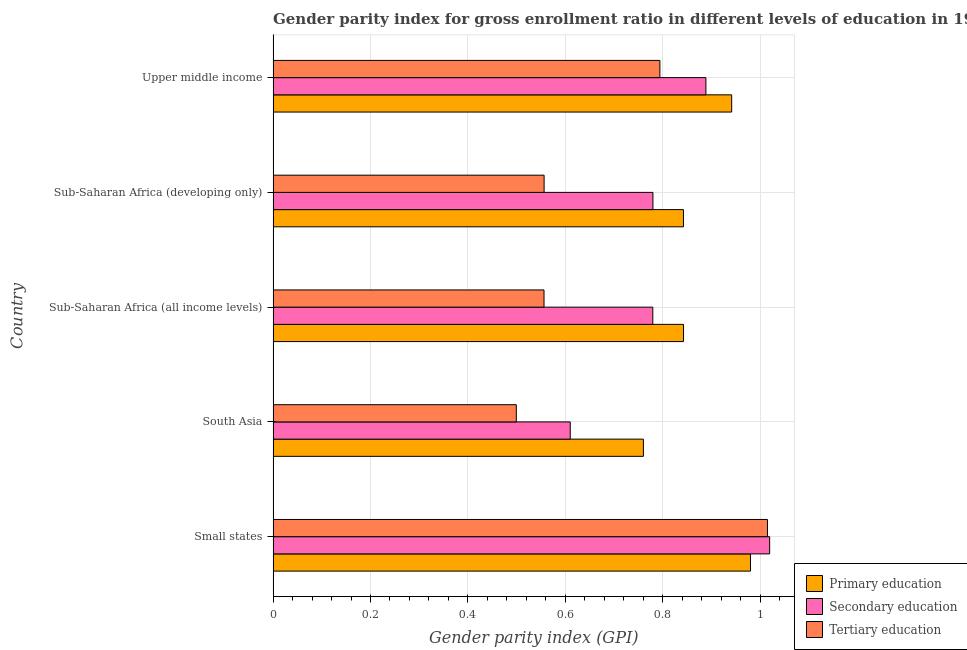How many groups of bars are there?
Provide a short and direct response. 5. Are the number of bars on each tick of the Y-axis equal?
Your answer should be compact. Yes. How many bars are there on the 4th tick from the top?
Provide a short and direct response. 3. How many bars are there on the 4th tick from the bottom?
Ensure brevity in your answer.  3. What is the label of the 4th group of bars from the top?
Provide a short and direct response. South Asia. In how many cases, is the number of bars for a given country not equal to the number of legend labels?
Offer a terse response. 0. What is the gender parity index in tertiary education in South Asia?
Provide a succinct answer. 0.5. Across all countries, what is the maximum gender parity index in tertiary education?
Ensure brevity in your answer.  1.02. Across all countries, what is the minimum gender parity index in primary education?
Your answer should be compact. 0.76. In which country was the gender parity index in secondary education maximum?
Provide a short and direct response. Small states. In which country was the gender parity index in tertiary education minimum?
Keep it short and to the point. South Asia. What is the total gender parity index in tertiary education in the graph?
Keep it short and to the point. 3.42. What is the difference between the gender parity index in tertiary education in Small states and that in Sub-Saharan Africa (developing only)?
Your response must be concise. 0.46. What is the difference between the gender parity index in secondary education in South Asia and the gender parity index in primary education in Sub-Saharan Africa (all income levels)?
Ensure brevity in your answer.  -0.23. What is the average gender parity index in primary education per country?
Provide a succinct answer. 0.87. What is the difference between the gender parity index in tertiary education and gender parity index in secondary education in South Asia?
Keep it short and to the point. -0.11. What is the ratio of the gender parity index in secondary education in Small states to that in Sub-Saharan Africa (all income levels)?
Your response must be concise. 1.31. What is the difference between the highest and the second highest gender parity index in primary education?
Your response must be concise. 0.04. What is the difference between the highest and the lowest gender parity index in primary education?
Give a very brief answer. 0.22. In how many countries, is the gender parity index in tertiary education greater than the average gender parity index in tertiary education taken over all countries?
Provide a succinct answer. 2. Is the sum of the gender parity index in primary education in Small states and Sub-Saharan Africa (all income levels) greater than the maximum gender parity index in tertiary education across all countries?
Your answer should be compact. Yes. What does the 3rd bar from the top in South Asia represents?
Provide a short and direct response. Primary education. What does the 2nd bar from the bottom in Sub-Saharan Africa (all income levels) represents?
Offer a terse response. Secondary education. Are all the bars in the graph horizontal?
Offer a very short reply. Yes. How many countries are there in the graph?
Offer a terse response. 5. Are the values on the major ticks of X-axis written in scientific E-notation?
Give a very brief answer. No. Does the graph contain any zero values?
Give a very brief answer. No. Does the graph contain grids?
Your answer should be compact. Yes. Where does the legend appear in the graph?
Provide a short and direct response. Bottom right. How are the legend labels stacked?
Your response must be concise. Vertical. What is the title of the graph?
Keep it short and to the point. Gender parity index for gross enrollment ratio in different levels of education in 1992. What is the label or title of the X-axis?
Make the answer very short. Gender parity index (GPI). What is the label or title of the Y-axis?
Provide a short and direct response. Country. What is the Gender parity index (GPI) in Primary education in Small states?
Your answer should be very brief. 0.98. What is the Gender parity index (GPI) of Secondary education in Small states?
Your answer should be compact. 1.02. What is the Gender parity index (GPI) in Tertiary education in Small states?
Offer a very short reply. 1.02. What is the Gender parity index (GPI) in Primary education in South Asia?
Offer a very short reply. 0.76. What is the Gender parity index (GPI) in Secondary education in South Asia?
Provide a short and direct response. 0.61. What is the Gender parity index (GPI) in Tertiary education in South Asia?
Provide a short and direct response. 0.5. What is the Gender parity index (GPI) in Primary education in Sub-Saharan Africa (all income levels)?
Your answer should be very brief. 0.84. What is the Gender parity index (GPI) in Secondary education in Sub-Saharan Africa (all income levels)?
Provide a succinct answer. 0.78. What is the Gender parity index (GPI) of Tertiary education in Sub-Saharan Africa (all income levels)?
Provide a short and direct response. 0.56. What is the Gender parity index (GPI) in Primary education in Sub-Saharan Africa (developing only)?
Your answer should be very brief. 0.84. What is the Gender parity index (GPI) of Secondary education in Sub-Saharan Africa (developing only)?
Your answer should be compact. 0.78. What is the Gender parity index (GPI) of Tertiary education in Sub-Saharan Africa (developing only)?
Offer a terse response. 0.56. What is the Gender parity index (GPI) of Primary education in Upper middle income?
Your response must be concise. 0.94. What is the Gender parity index (GPI) in Secondary education in Upper middle income?
Offer a terse response. 0.89. What is the Gender parity index (GPI) in Tertiary education in Upper middle income?
Your response must be concise. 0.79. Across all countries, what is the maximum Gender parity index (GPI) of Primary education?
Your answer should be compact. 0.98. Across all countries, what is the maximum Gender parity index (GPI) in Secondary education?
Your response must be concise. 1.02. Across all countries, what is the maximum Gender parity index (GPI) in Tertiary education?
Provide a short and direct response. 1.02. Across all countries, what is the minimum Gender parity index (GPI) in Primary education?
Offer a terse response. 0.76. Across all countries, what is the minimum Gender parity index (GPI) of Secondary education?
Give a very brief answer. 0.61. Across all countries, what is the minimum Gender parity index (GPI) in Tertiary education?
Offer a terse response. 0.5. What is the total Gender parity index (GPI) of Primary education in the graph?
Your response must be concise. 4.37. What is the total Gender parity index (GPI) of Secondary education in the graph?
Give a very brief answer. 4.08. What is the total Gender parity index (GPI) in Tertiary education in the graph?
Ensure brevity in your answer.  3.42. What is the difference between the Gender parity index (GPI) in Primary education in Small states and that in South Asia?
Your answer should be very brief. 0.22. What is the difference between the Gender parity index (GPI) of Secondary education in Small states and that in South Asia?
Keep it short and to the point. 0.41. What is the difference between the Gender parity index (GPI) of Tertiary education in Small states and that in South Asia?
Your response must be concise. 0.52. What is the difference between the Gender parity index (GPI) of Primary education in Small states and that in Sub-Saharan Africa (all income levels)?
Offer a very short reply. 0.14. What is the difference between the Gender parity index (GPI) in Secondary education in Small states and that in Sub-Saharan Africa (all income levels)?
Your answer should be compact. 0.24. What is the difference between the Gender parity index (GPI) of Tertiary education in Small states and that in Sub-Saharan Africa (all income levels)?
Give a very brief answer. 0.46. What is the difference between the Gender parity index (GPI) in Primary education in Small states and that in Sub-Saharan Africa (developing only)?
Offer a terse response. 0.14. What is the difference between the Gender parity index (GPI) of Secondary education in Small states and that in Sub-Saharan Africa (developing only)?
Your answer should be compact. 0.24. What is the difference between the Gender parity index (GPI) in Tertiary education in Small states and that in Sub-Saharan Africa (developing only)?
Offer a very short reply. 0.46. What is the difference between the Gender parity index (GPI) of Primary education in Small states and that in Upper middle income?
Ensure brevity in your answer.  0.04. What is the difference between the Gender parity index (GPI) in Secondary education in Small states and that in Upper middle income?
Keep it short and to the point. 0.13. What is the difference between the Gender parity index (GPI) of Tertiary education in Small states and that in Upper middle income?
Your answer should be compact. 0.22. What is the difference between the Gender parity index (GPI) of Primary education in South Asia and that in Sub-Saharan Africa (all income levels)?
Ensure brevity in your answer.  -0.08. What is the difference between the Gender parity index (GPI) of Secondary education in South Asia and that in Sub-Saharan Africa (all income levels)?
Offer a terse response. -0.17. What is the difference between the Gender parity index (GPI) in Tertiary education in South Asia and that in Sub-Saharan Africa (all income levels)?
Ensure brevity in your answer.  -0.06. What is the difference between the Gender parity index (GPI) of Primary education in South Asia and that in Sub-Saharan Africa (developing only)?
Offer a very short reply. -0.08. What is the difference between the Gender parity index (GPI) in Secondary education in South Asia and that in Sub-Saharan Africa (developing only)?
Keep it short and to the point. -0.17. What is the difference between the Gender parity index (GPI) of Tertiary education in South Asia and that in Sub-Saharan Africa (developing only)?
Make the answer very short. -0.06. What is the difference between the Gender parity index (GPI) in Primary education in South Asia and that in Upper middle income?
Offer a very short reply. -0.18. What is the difference between the Gender parity index (GPI) of Secondary education in South Asia and that in Upper middle income?
Your answer should be compact. -0.28. What is the difference between the Gender parity index (GPI) in Tertiary education in South Asia and that in Upper middle income?
Your response must be concise. -0.29. What is the difference between the Gender parity index (GPI) in Primary education in Sub-Saharan Africa (all income levels) and that in Sub-Saharan Africa (developing only)?
Your response must be concise. 0. What is the difference between the Gender parity index (GPI) of Secondary education in Sub-Saharan Africa (all income levels) and that in Sub-Saharan Africa (developing only)?
Your answer should be compact. -0. What is the difference between the Gender parity index (GPI) in Tertiary education in Sub-Saharan Africa (all income levels) and that in Sub-Saharan Africa (developing only)?
Ensure brevity in your answer.  -0. What is the difference between the Gender parity index (GPI) of Primary education in Sub-Saharan Africa (all income levels) and that in Upper middle income?
Provide a short and direct response. -0.1. What is the difference between the Gender parity index (GPI) of Secondary education in Sub-Saharan Africa (all income levels) and that in Upper middle income?
Make the answer very short. -0.11. What is the difference between the Gender parity index (GPI) of Tertiary education in Sub-Saharan Africa (all income levels) and that in Upper middle income?
Offer a terse response. -0.24. What is the difference between the Gender parity index (GPI) of Primary education in Sub-Saharan Africa (developing only) and that in Upper middle income?
Provide a succinct answer. -0.1. What is the difference between the Gender parity index (GPI) in Secondary education in Sub-Saharan Africa (developing only) and that in Upper middle income?
Offer a terse response. -0.11. What is the difference between the Gender parity index (GPI) of Tertiary education in Sub-Saharan Africa (developing only) and that in Upper middle income?
Provide a short and direct response. -0.24. What is the difference between the Gender parity index (GPI) of Primary education in Small states and the Gender parity index (GPI) of Secondary education in South Asia?
Your response must be concise. 0.37. What is the difference between the Gender parity index (GPI) of Primary education in Small states and the Gender parity index (GPI) of Tertiary education in South Asia?
Give a very brief answer. 0.48. What is the difference between the Gender parity index (GPI) of Secondary education in Small states and the Gender parity index (GPI) of Tertiary education in South Asia?
Give a very brief answer. 0.52. What is the difference between the Gender parity index (GPI) of Primary education in Small states and the Gender parity index (GPI) of Secondary education in Sub-Saharan Africa (all income levels)?
Keep it short and to the point. 0.2. What is the difference between the Gender parity index (GPI) in Primary education in Small states and the Gender parity index (GPI) in Tertiary education in Sub-Saharan Africa (all income levels)?
Ensure brevity in your answer.  0.42. What is the difference between the Gender parity index (GPI) of Secondary education in Small states and the Gender parity index (GPI) of Tertiary education in Sub-Saharan Africa (all income levels)?
Ensure brevity in your answer.  0.46. What is the difference between the Gender parity index (GPI) of Primary education in Small states and the Gender parity index (GPI) of Secondary education in Sub-Saharan Africa (developing only)?
Offer a terse response. 0.2. What is the difference between the Gender parity index (GPI) in Primary education in Small states and the Gender parity index (GPI) in Tertiary education in Sub-Saharan Africa (developing only)?
Your response must be concise. 0.42. What is the difference between the Gender parity index (GPI) of Secondary education in Small states and the Gender parity index (GPI) of Tertiary education in Sub-Saharan Africa (developing only)?
Offer a terse response. 0.46. What is the difference between the Gender parity index (GPI) in Primary education in Small states and the Gender parity index (GPI) in Secondary education in Upper middle income?
Offer a terse response. 0.09. What is the difference between the Gender parity index (GPI) of Primary education in Small states and the Gender parity index (GPI) of Tertiary education in Upper middle income?
Provide a succinct answer. 0.19. What is the difference between the Gender parity index (GPI) of Secondary education in Small states and the Gender parity index (GPI) of Tertiary education in Upper middle income?
Your answer should be compact. 0.23. What is the difference between the Gender parity index (GPI) of Primary education in South Asia and the Gender parity index (GPI) of Secondary education in Sub-Saharan Africa (all income levels)?
Provide a succinct answer. -0.02. What is the difference between the Gender parity index (GPI) in Primary education in South Asia and the Gender parity index (GPI) in Tertiary education in Sub-Saharan Africa (all income levels)?
Offer a terse response. 0.2. What is the difference between the Gender parity index (GPI) in Secondary education in South Asia and the Gender parity index (GPI) in Tertiary education in Sub-Saharan Africa (all income levels)?
Make the answer very short. 0.05. What is the difference between the Gender parity index (GPI) in Primary education in South Asia and the Gender parity index (GPI) in Secondary education in Sub-Saharan Africa (developing only)?
Give a very brief answer. -0.02. What is the difference between the Gender parity index (GPI) in Primary education in South Asia and the Gender parity index (GPI) in Tertiary education in Sub-Saharan Africa (developing only)?
Keep it short and to the point. 0.2. What is the difference between the Gender parity index (GPI) in Secondary education in South Asia and the Gender parity index (GPI) in Tertiary education in Sub-Saharan Africa (developing only)?
Offer a very short reply. 0.05. What is the difference between the Gender parity index (GPI) in Primary education in South Asia and the Gender parity index (GPI) in Secondary education in Upper middle income?
Provide a short and direct response. -0.13. What is the difference between the Gender parity index (GPI) in Primary education in South Asia and the Gender parity index (GPI) in Tertiary education in Upper middle income?
Your answer should be compact. -0.03. What is the difference between the Gender parity index (GPI) of Secondary education in South Asia and the Gender parity index (GPI) of Tertiary education in Upper middle income?
Offer a very short reply. -0.18. What is the difference between the Gender parity index (GPI) in Primary education in Sub-Saharan Africa (all income levels) and the Gender parity index (GPI) in Secondary education in Sub-Saharan Africa (developing only)?
Provide a succinct answer. 0.06. What is the difference between the Gender parity index (GPI) of Primary education in Sub-Saharan Africa (all income levels) and the Gender parity index (GPI) of Tertiary education in Sub-Saharan Africa (developing only)?
Ensure brevity in your answer.  0.29. What is the difference between the Gender parity index (GPI) in Secondary education in Sub-Saharan Africa (all income levels) and the Gender parity index (GPI) in Tertiary education in Sub-Saharan Africa (developing only)?
Offer a very short reply. 0.22. What is the difference between the Gender parity index (GPI) of Primary education in Sub-Saharan Africa (all income levels) and the Gender parity index (GPI) of Secondary education in Upper middle income?
Give a very brief answer. -0.05. What is the difference between the Gender parity index (GPI) in Primary education in Sub-Saharan Africa (all income levels) and the Gender parity index (GPI) in Tertiary education in Upper middle income?
Provide a short and direct response. 0.05. What is the difference between the Gender parity index (GPI) of Secondary education in Sub-Saharan Africa (all income levels) and the Gender parity index (GPI) of Tertiary education in Upper middle income?
Provide a succinct answer. -0.01. What is the difference between the Gender parity index (GPI) of Primary education in Sub-Saharan Africa (developing only) and the Gender parity index (GPI) of Secondary education in Upper middle income?
Keep it short and to the point. -0.05. What is the difference between the Gender parity index (GPI) of Primary education in Sub-Saharan Africa (developing only) and the Gender parity index (GPI) of Tertiary education in Upper middle income?
Your answer should be very brief. 0.05. What is the difference between the Gender parity index (GPI) in Secondary education in Sub-Saharan Africa (developing only) and the Gender parity index (GPI) in Tertiary education in Upper middle income?
Your answer should be compact. -0.01. What is the average Gender parity index (GPI) in Primary education per country?
Ensure brevity in your answer.  0.87. What is the average Gender parity index (GPI) of Secondary education per country?
Offer a terse response. 0.82. What is the average Gender parity index (GPI) in Tertiary education per country?
Provide a short and direct response. 0.68. What is the difference between the Gender parity index (GPI) in Primary education and Gender parity index (GPI) in Secondary education in Small states?
Give a very brief answer. -0.04. What is the difference between the Gender parity index (GPI) of Primary education and Gender parity index (GPI) of Tertiary education in Small states?
Your answer should be compact. -0.03. What is the difference between the Gender parity index (GPI) in Secondary education and Gender parity index (GPI) in Tertiary education in Small states?
Ensure brevity in your answer.  0. What is the difference between the Gender parity index (GPI) in Primary education and Gender parity index (GPI) in Secondary education in South Asia?
Your answer should be compact. 0.15. What is the difference between the Gender parity index (GPI) of Primary education and Gender parity index (GPI) of Tertiary education in South Asia?
Give a very brief answer. 0.26. What is the difference between the Gender parity index (GPI) of Secondary education and Gender parity index (GPI) of Tertiary education in South Asia?
Your answer should be very brief. 0.11. What is the difference between the Gender parity index (GPI) in Primary education and Gender parity index (GPI) in Secondary education in Sub-Saharan Africa (all income levels)?
Your answer should be very brief. 0.06. What is the difference between the Gender parity index (GPI) in Primary education and Gender parity index (GPI) in Tertiary education in Sub-Saharan Africa (all income levels)?
Make the answer very short. 0.29. What is the difference between the Gender parity index (GPI) in Secondary education and Gender parity index (GPI) in Tertiary education in Sub-Saharan Africa (all income levels)?
Provide a succinct answer. 0.22. What is the difference between the Gender parity index (GPI) in Primary education and Gender parity index (GPI) in Secondary education in Sub-Saharan Africa (developing only)?
Make the answer very short. 0.06. What is the difference between the Gender parity index (GPI) in Primary education and Gender parity index (GPI) in Tertiary education in Sub-Saharan Africa (developing only)?
Make the answer very short. 0.29. What is the difference between the Gender parity index (GPI) in Secondary education and Gender parity index (GPI) in Tertiary education in Sub-Saharan Africa (developing only)?
Provide a succinct answer. 0.22. What is the difference between the Gender parity index (GPI) in Primary education and Gender parity index (GPI) in Secondary education in Upper middle income?
Offer a very short reply. 0.05. What is the difference between the Gender parity index (GPI) of Primary education and Gender parity index (GPI) of Tertiary education in Upper middle income?
Ensure brevity in your answer.  0.15. What is the difference between the Gender parity index (GPI) of Secondary education and Gender parity index (GPI) of Tertiary education in Upper middle income?
Provide a short and direct response. 0.09. What is the ratio of the Gender parity index (GPI) in Primary education in Small states to that in South Asia?
Provide a short and direct response. 1.29. What is the ratio of the Gender parity index (GPI) in Secondary education in Small states to that in South Asia?
Provide a short and direct response. 1.67. What is the ratio of the Gender parity index (GPI) of Tertiary education in Small states to that in South Asia?
Provide a short and direct response. 2.03. What is the ratio of the Gender parity index (GPI) of Primary education in Small states to that in Sub-Saharan Africa (all income levels)?
Offer a very short reply. 1.16. What is the ratio of the Gender parity index (GPI) in Secondary education in Small states to that in Sub-Saharan Africa (all income levels)?
Your answer should be very brief. 1.31. What is the ratio of the Gender parity index (GPI) in Tertiary education in Small states to that in Sub-Saharan Africa (all income levels)?
Offer a very short reply. 1.82. What is the ratio of the Gender parity index (GPI) of Primary education in Small states to that in Sub-Saharan Africa (developing only)?
Your answer should be compact. 1.16. What is the ratio of the Gender parity index (GPI) of Secondary education in Small states to that in Sub-Saharan Africa (developing only)?
Your answer should be very brief. 1.31. What is the ratio of the Gender parity index (GPI) of Tertiary education in Small states to that in Sub-Saharan Africa (developing only)?
Offer a very short reply. 1.82. What is the ratio of the Gender parity index (GPI) in Primary education in Small states to that in Upper middle income?
Ensure brevity in your answer.  1.04. What is the ratio of the Gender parity index (GPI) of Secondary education in Small states to that in Upper middle income?
Keep it short and to the point. 1.15. What is the ratio of the Gender parity index (GPI) of Tertiary education in Small states to that in Upper middle income?
Your response must be concise. 1.28. What is the ratio of the Gender parity index (GPI) in Primary education in South Asia to that in Sub-Saharan Africa (all income levels)?
Provide a short and direct response. 0.9. What is the ratio of the Gender parity index (GPI) of Secondary education in South Asia to that in Sub-Saharan Africa (all income levels)?
Make the answer very short. 0.78. What is the ratio of the Gender parity index (GPI) in Tertiary education in South Asia to that in Sub-Saharan Africa (all income levels)?
Your answer should be very brief. 0.9. What is the ratio of the Gender parity index (GPI) of Primary education in South Asia to that in Sub-Saharan Africa (developing only)?
Provide a succinct answer. 0.9. What is the ratio of the Gender parity index (GPI) in Secondary education in South Asia to that in Sub-Saharan Africa (developing only)?
Your answer should be very brief. 0.78. What is the ratio of the Gender parity index (GPI) of Tertiary education in South Asia to that in Sub-Saharan Africa (developing only)?
Provide a short and direct response. 0.9. What is the ratio of the Gender parity index (GPI) in Primary education in South Asia to that in Upper middle income?
Provide a succinct answer. 0.81. What is the ratio of the Gender parity index (GPI) of Secondary education in South Asia to that in Upper middle income?
Your answer should be very brief. 0.69. What is the ratio of the Gender parity index (GPI) of Tertiary education in South Asia to that in Upper middle income?
Offer a very short reply. 0.63. What is the ratio of the Gender parity index (GPI) in Tertiary education in Sub-Saharan Africa (all income levels) to that in Sub-Saharan Africa (developing only)?
Your answer should be very brief. 1. What is the ratio of the Gender parity index (GPI) in Primary education in Sub-Saharan Africa (all income levels) to that in Upper middle income?
Your answer should be very brief. 0.9. What is the ratio of the Gender parity index (GPI) in Secondary education in Sub-Saharan Africa (all income levels) to that in Upper middle income?
Keep it short and to the point. 0.88. What is the ratio of the Gender parity index (GPI) of Tertiary education in Sub-Saharan Africa (all income levels) to that in Upper middle income?
Your answer should be compact. 0.7. What is the ratio of the Gender parity index (GPI) in Primary education in Sub-Saharan Africa (developing only) to that in Upper middle income?
Offer a very short reply. 0.89. What is the ratio of the Gender parity index (GPI) of Secondary education in Sub-Saharan Africa (developing only) to that in Upper middle income?
Provide a succinct answer. 0.88. What is the ratio of the Gender parity index (GPI) in Tertiary education in Sub-Saharan Africa (developing only) to that in Upper middle income?
Ensure brevity in your answer.  0.7. What is the difference between the highest and the second highest Gender parity index (GPI) of Primary education?
Your answer should be very brief. 0.04. What is the difference between the highest and the second highest Gender parity index (GPI) in Secondary education?
Your answer should be compact. 0.13. What is the difference between the highest and the second highest Gender parity index (GPI) of Tertiary education?
Make the answer very short. 0.22. What is the difference between the highest and the lowest Gender parity index (GPI) in Primary education?
Offer a very short reply. 0.22. What is the difference between the highest and the lowest Gender parity index (GPI) of Secondary education?
Your answer should be very brief. 0.41. What is the difference between the highest and the lowest Gender parity index (GPI) in Tertiary education?
Provide a short and direct response. 0.52. 